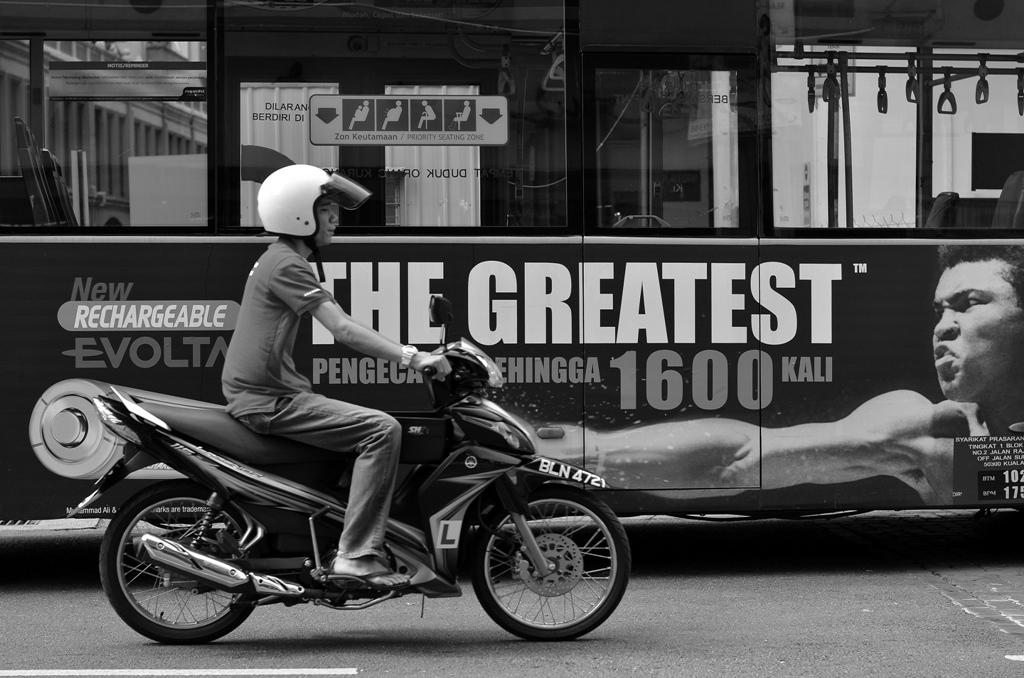What is the man in the image doing? The man is riding a motorcycle in the image. Where is the man riding the motorcycle? The man is on the road. What is behind the motorcycle in the image? There is a bus behind the motorcycle. What can be seen on the bus in the image? The bus has an advertisement featuring a man. What type of polish is being applied to the motorcycle in the image? There is no indication in the image that any polish is being applied to the motorcycle. 